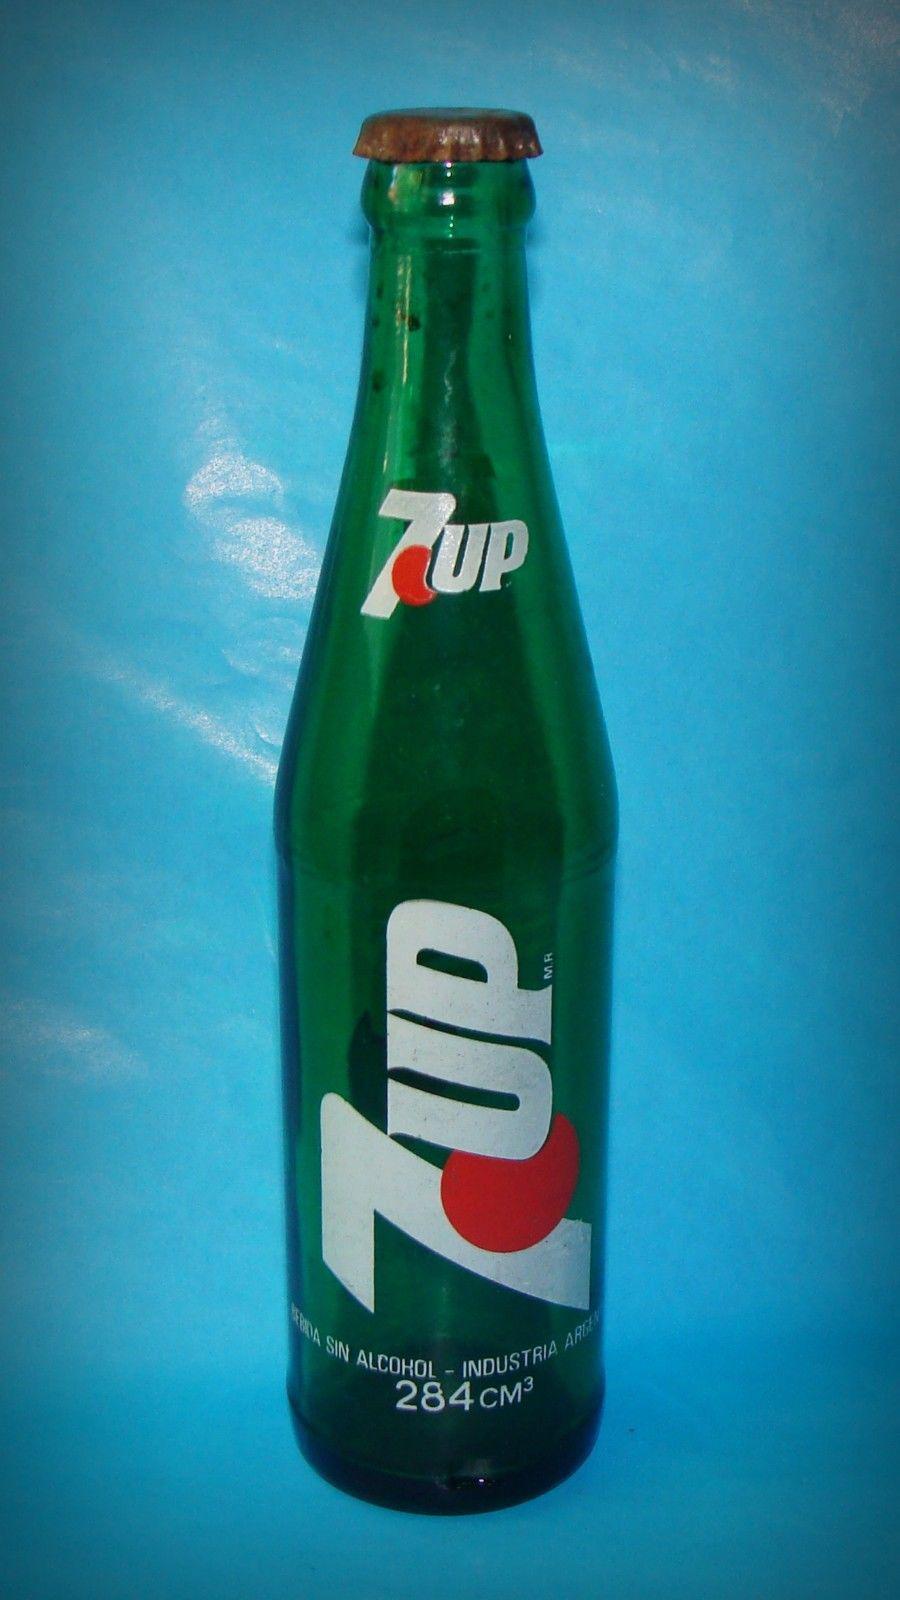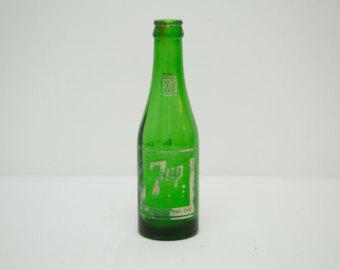The first image is the image on the left, the second image is the image on the right. For the images shown, is this caption "There are only 7-up bottles in each image." true? Answer yes or no. Yes. The first image is the image on the left, the second image is the image on the right. Assess this claim about the two images: "The right image contains two matching green bottles with the same labels, and no image contains cans.". Correct or not? Answer yes or no. No. 